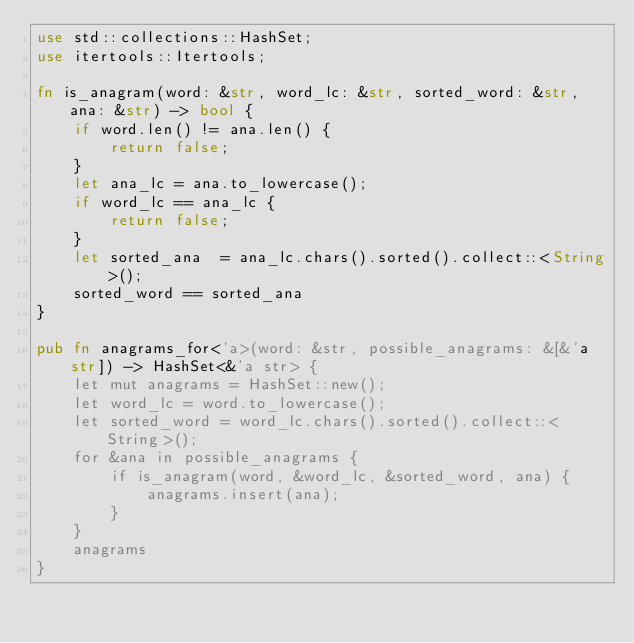Convert code to text. <code><loc_0><loc_0><loc_500><loc_500><_Rust_>use std::collections::HashSet;
use itertools::Itertools;

fn is_anagram(word: &str, word_lc: &str, sorted_word: &str, ana: &str) -> bool {
    if word.len() != ana.len() {
        return false;
    }
    let ana_lc = ana.to_lowercase();
    if word_lc == ana_lc {
        return false;
    }
    let sorted_ana  = ana_lc.chars().sorted().collect::<String>();
    sorted_word == sorted_ana
}

pub fn anagrams_for<'a>(word: &str, possible_anagrams: &[&'a str]) -> HashSet<&'a str> {
    let mut anagrams = HashSet::new();
    let word_lc = word.to_lowercase();
    let sorted_word = word_lc.chars().sorted().collect::<String>();
    for &ana in possible_anagrams {
        if is_anagram(word, &word_lc, &sorted_word, ana) {
            anagrams.insert(ana);
        }
    }
    anagrams
}
</code> 